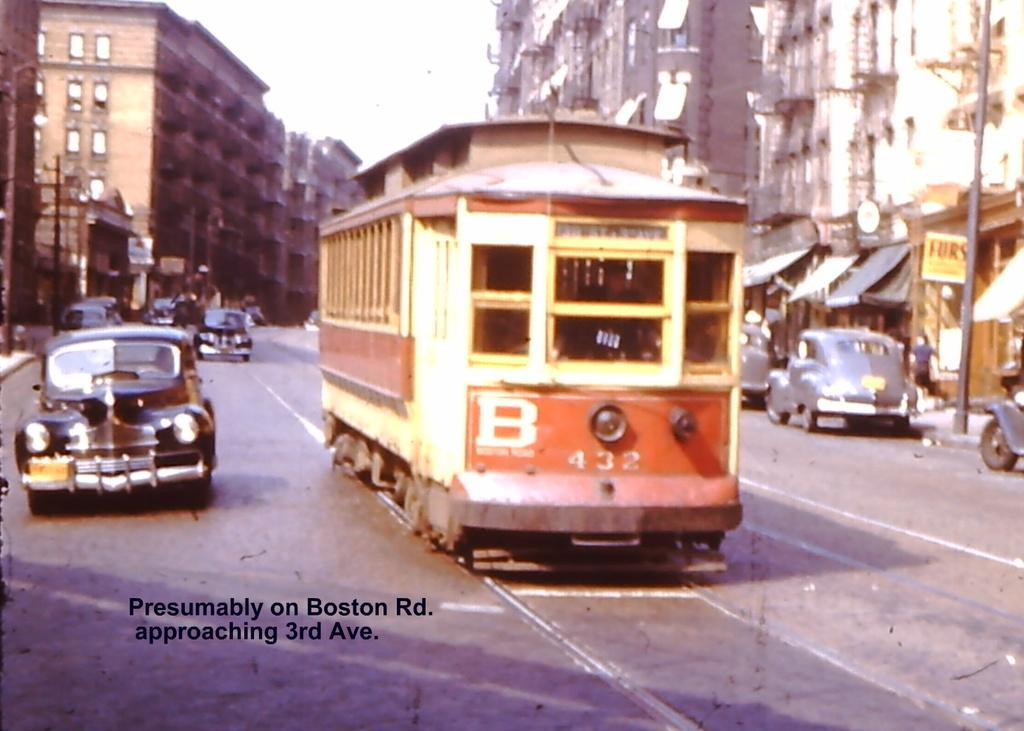<image>
Render a clear and concise summary of the photo. An old photo of a street car and a motor car with the writing "presumably Boston" written on it. 